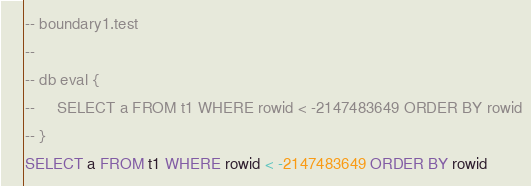Convert code to text. <code><loc_0><loc_0><loc_500><loc_500><_SQL_>-- boundary1.test
-- 
-- db eval {
--     SELECT a FROM t1 WHERE rowid < -2147483649 ORDER BY rowid
-- }
SELECT a FROM t1 WHERE rowid < -2147483649 ORDER BY rowid</code> 